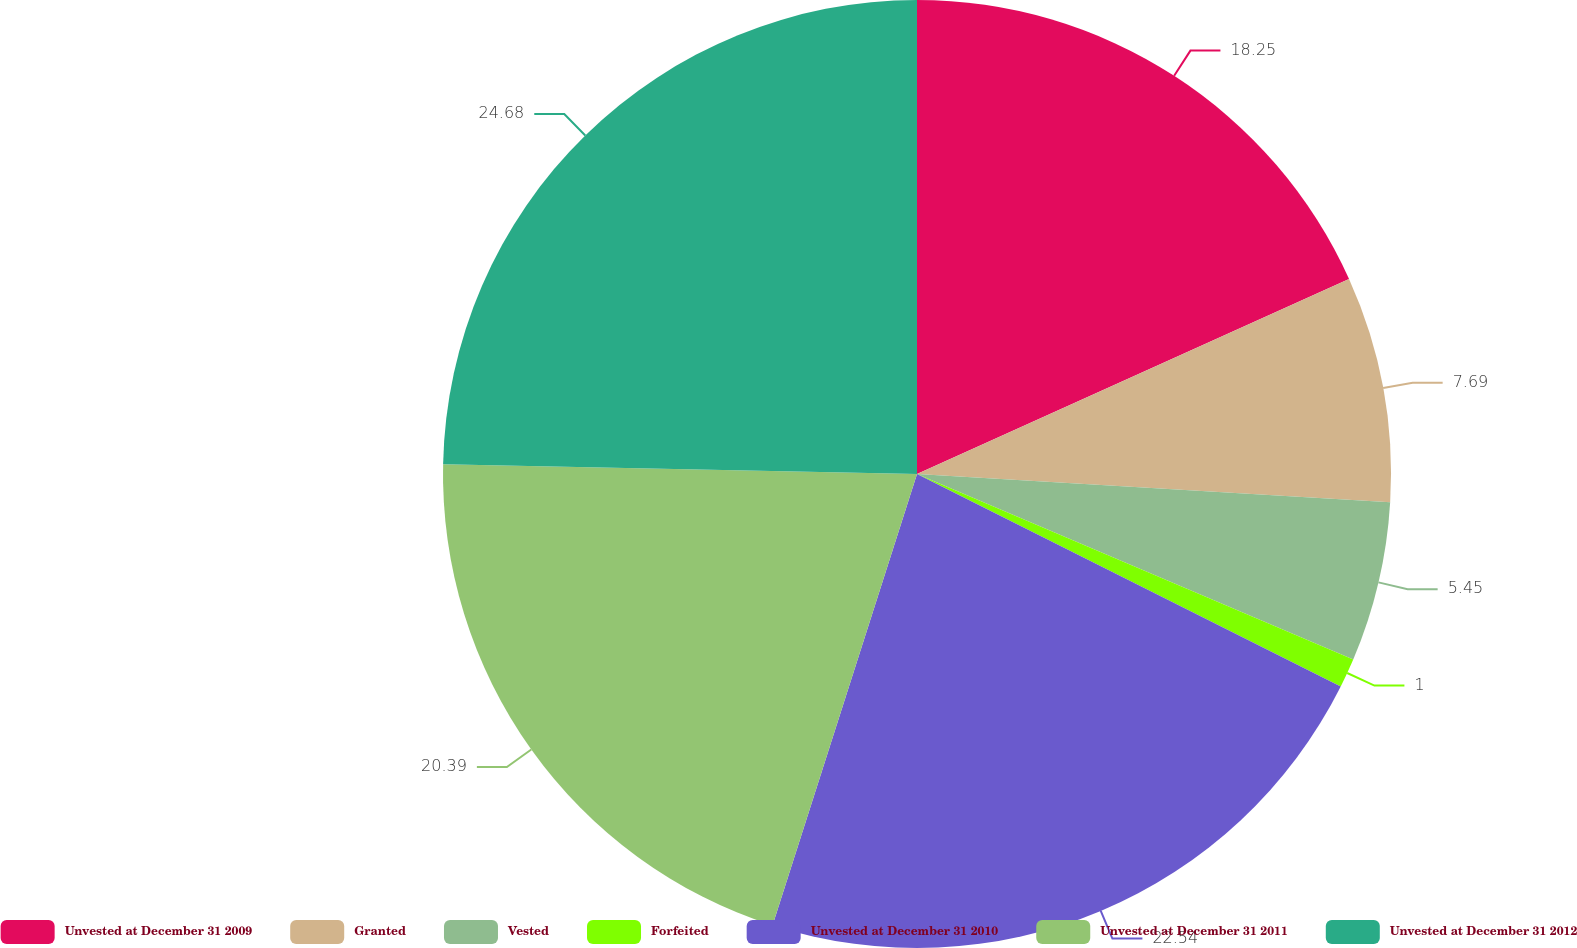<chart> <loc_0><loc_0><loc_500><loc_500><pie_chart><fcel>Unvested at December 31 2009<fcel>Granted<fcel>Vested<fcel>Forfeited<fcel>Unvested at December 31 2010<fcel>Unvested at December 31 2011<fcel>Unvested at December 31 2012<nl><fcel>18.25%<fcel>7.69%<fcel>5.45%<fcel>1.0%<fcel>22.53%<fcel>20.39%<fcel>24.67%<nl></chart> 